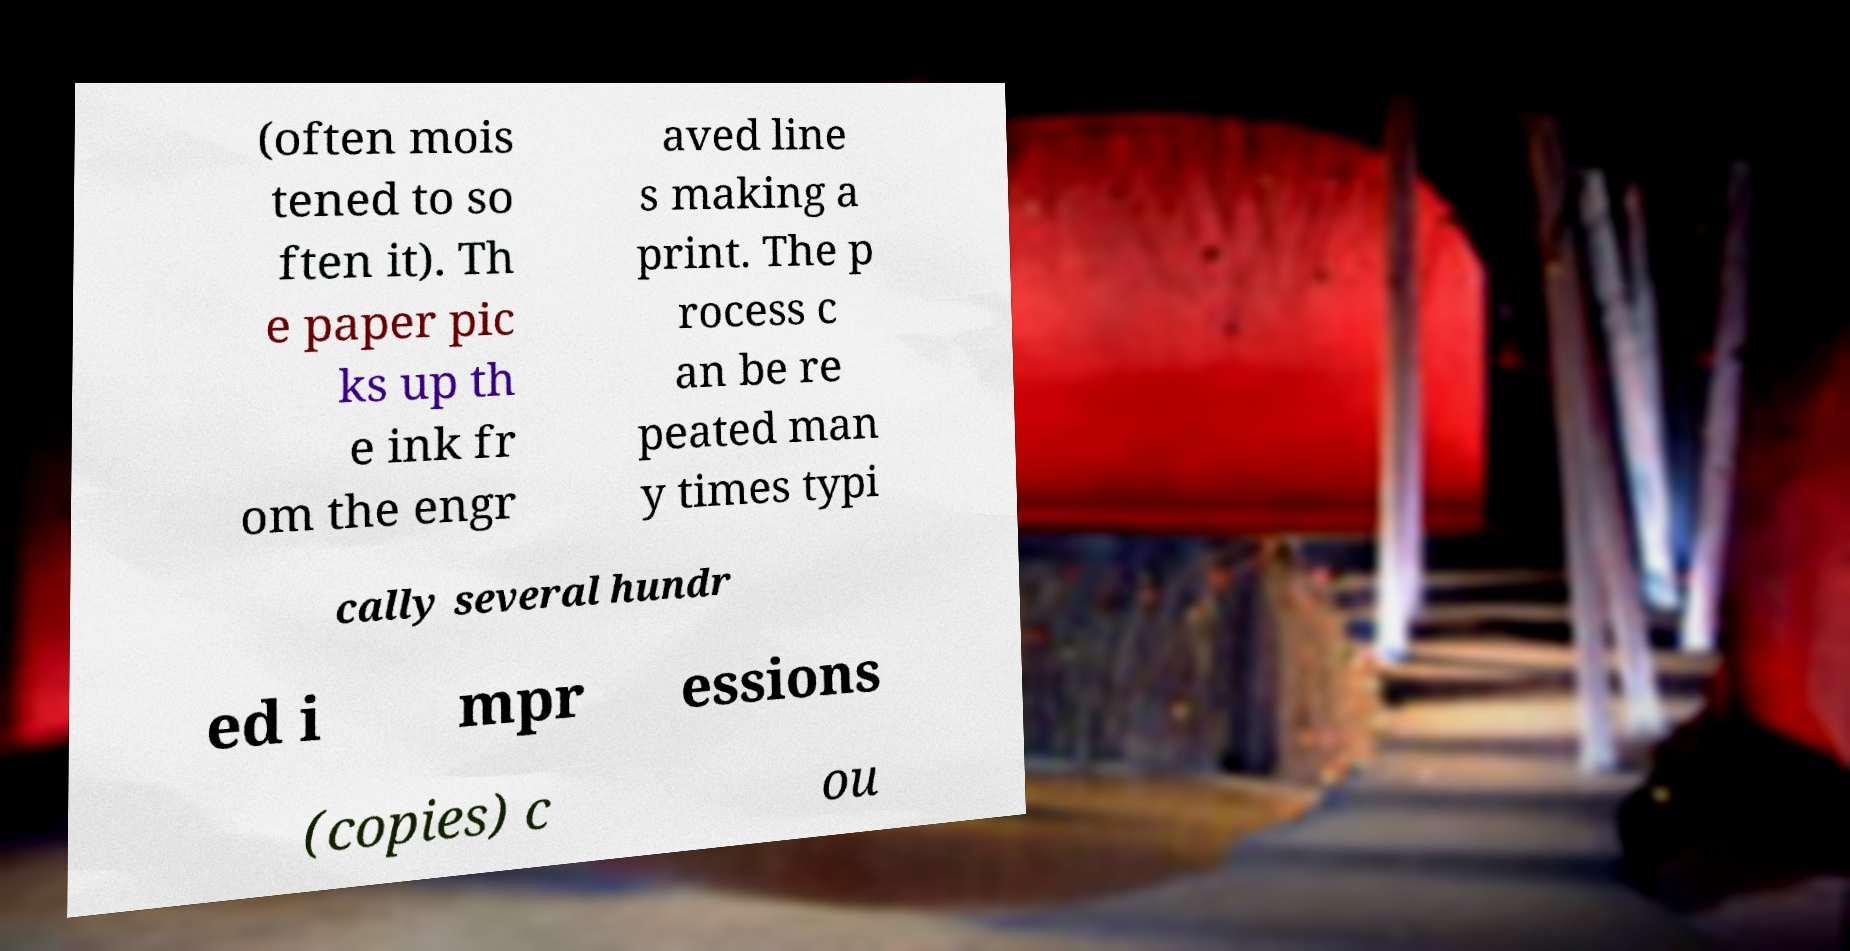I need the written content from this picture converted into text. Can you do that? (often mois tened to so ften it). Th e paper pic ks up th e ink fr om the engr aved line s making a print. The p rocess c an be re peated man y times typi cally several hundr ed i mpr essions (copies) c ou 